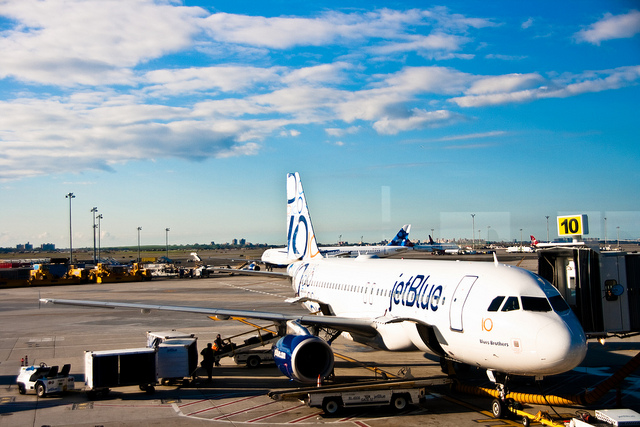Please identify all text content in this image. 10 jetBlue 